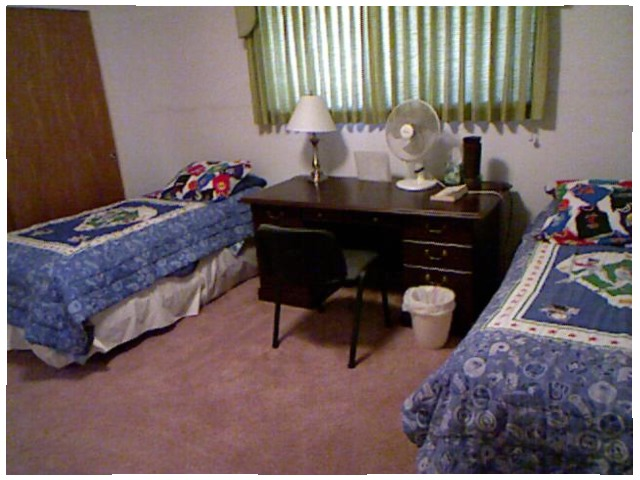<image>
Is the fan on the table? Yes. Looking at the image, I can see the fan is positioned on top of the table, with the table providing support. Is the drawer behind the bed? No. The drawer is not behind the bed. From this viewpoint, the drawer appears to be positioned elsewhere in the scene. Where is the table fan in relation to the waste bin? Is it above the waste bin? Yes. The table fan is positioned above the waste bin in the vertical space, higher up in the scene. Where is the bed in relation to the bed? Is it to the left of the bed? Yes. From this viewpoint, the bed is positioned to the left side relative to the bed. 